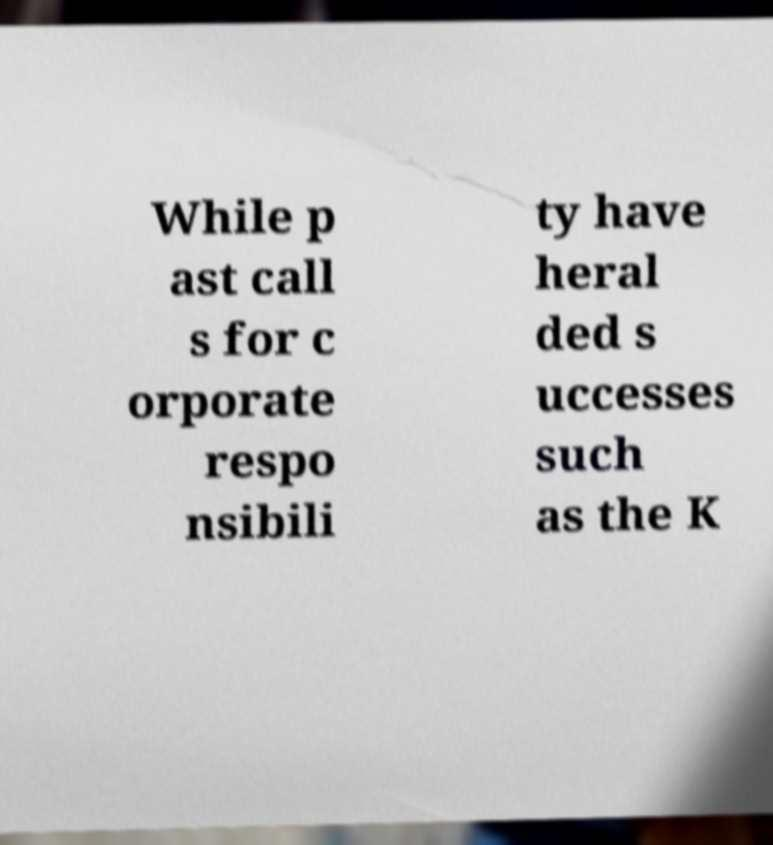Could you assist in decoding the text presented in this image and type it out clearly? While p ast call s for c orporate respo nsibili ty have heral ded s uccesses such as the K 